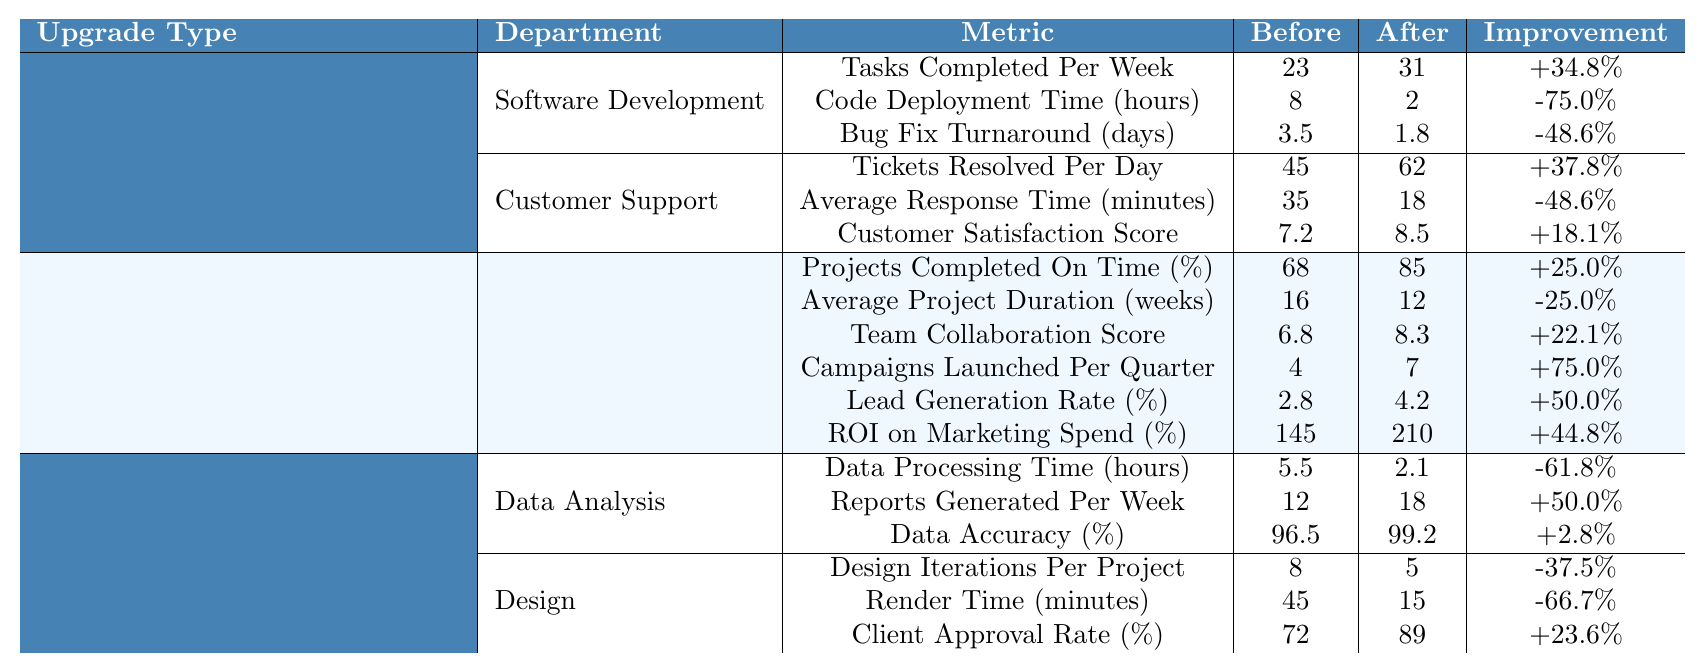What was the increase in tasks completed per week in the Software Development department after the cloud migration? Before the upgrade, the Software Development department completed 23 tasks per week. After the upgrade, they completed 31 tasks. The increase is 31 - 23 = 8 tasks, which is an increase of (8 / 23) * 100 = 34.8%.
Answer: 34.8% What was the average customer satisfaction score in the Customer Support department before the upgrade? The Customer Satisfaction Score in the Customer Support department before the upgrade was 7.2, which is stated directly in the table.
Answer: 7.2 How much did the average project duration decrease in the Product Management department after the upgrade? The average project duration decreased from 16 weeks before the upgrade to 12 weeks after the upgrade. The decrease is 16 - 12 = 4 weeks.
Answer: 4 weeks Was there an improvement in the tickets resolved per day in the Customer Support department after the cloud migration? Before the upgrade, the tickets resolved per day were 45, and after the upgrade, it increased to 62. Since 62 > 45, this is an improvement.
Answer: Yes Which department had the highest percentage improvement in projects completed on time after upgrading to the project management software? The Product Management department improved from 68% to 85%. The improvement percentage is (85 - 68) / 68 * 100 = 25%. The Marketing department improved from 4 to 7 campaigns launched per quarter, which is a 75% increase. Thus, Marketing had the highest percentage improvement.
Answer: Marketing What was the change in the lead generation rate (%) for the Marketing department before and after the upgrade? Before the upgrade, the lead generation rate was 2.8%, and after the upgrade, it increased to 4.2%. The change is 4.2 - 2.8 = 1.4%.
Answer: 1.4% Calculate the total improvement percentage across all metrics for the Data Analysis department after the hardware refresh. In the Data Analysis department, the metrics are:  - Data Processing Time improved by -61.8%  - Reports Generated Per Week improved by +50%  - Data Accuracy improved by +2.8%.  To find the total improvement: for improvements, take +50% and +2.8%, resulting in +52.8%, and for the reduction, take -61.8%. Therefore, the overall change is approximately +52.8% - 61.8% = -9%.
Answer: -9% What was the render time before the hardware refresh in the Design department? The render time before the hardware refresh was 45 minutes, as stated in the table.
Answer: 45 minutes How much did the bug fix turnaround time reduce from before to after the upgrade in the Software Development department? The bug fix turnaround time reduced from 3.5 days to 1.8 days after the upgrade. The reduction is 3.5 - 1.8 = 1.7 days.
Answer: 1.7 days Was the average response time in the Customer Support department halved after the cloud migration? The average response time decreased from 35 minutes to 18 minutes. This is not half because half of 35 is 17.5, and 18 is greater than 17.5, thus not halved.
Answer: No 